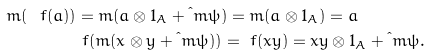Convert formula to latex. <formula><loc_0><loc_0><loc_500><loc_500>\bar { m } ( \ f ( a ) ) & = \bar { m } ( a \otimes 1 _ { A } + \i m \psi ) = m ( a \otimes 1 _ { A } ) = a \\ & \ f ( \bar { m } ( x \otimes y + \i m \psi ) ) = \ f ( x y ) = x y \otimes 1 _ { A } + \i m \psi .</formula> 